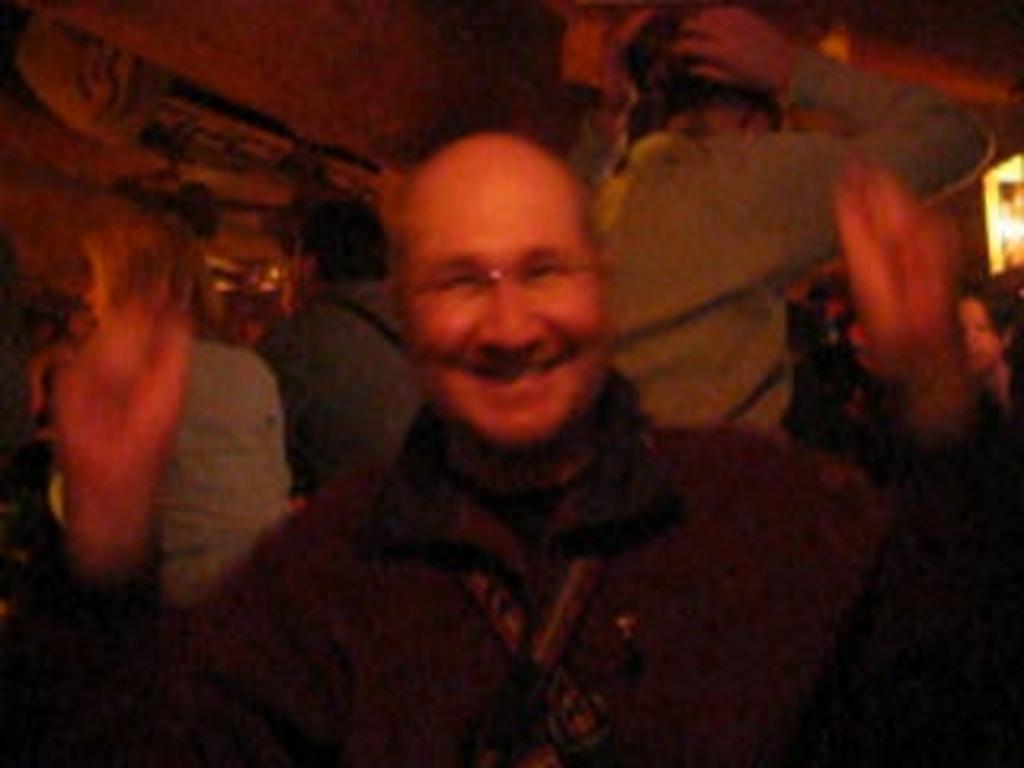How would you summarize this image in a sentence or two? Here in the middle we can see an old person in a black colored jacket present over there smiling and behind him also we can see other people sitting and standing all over the place. 